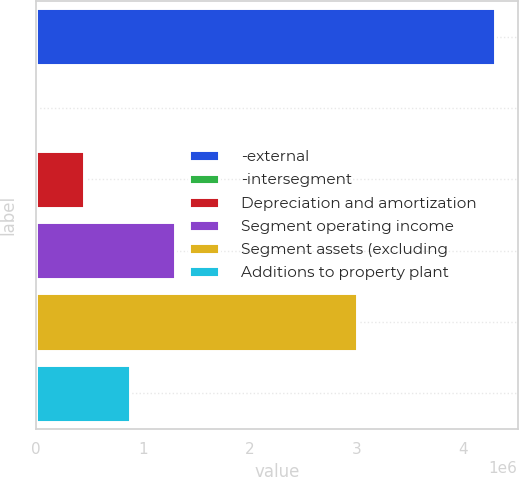<chart> <loc_0><loc_0><loc_500><loc_500><bar_chart><fcel>-external<fcel>-intersegment<fcel>Depreciation and amortization<fcel>Segment operating income<fcel>Segment assets (excluding<fcel>Additions to property plant<nl><fcel>4.29206e+06<fcel>24485<fcel>451243<fcel>1.30476e+06<fcel>3.00512e+06<fcel>878001<nl></chart> 